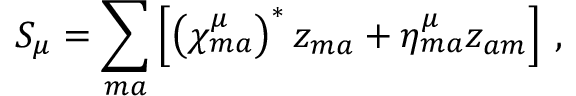<formula> <loc_0><loc_0><loc_500><loc_500>S _ { \mu } = \sum _ { m a } \left [ \left ( \chi _ { m a } ^ { \mu } \right ) ^ { * } z _ { m a } + \eta _ { m a } ^ { \mu } z _ { a m } \right ] \, ,</formula> 